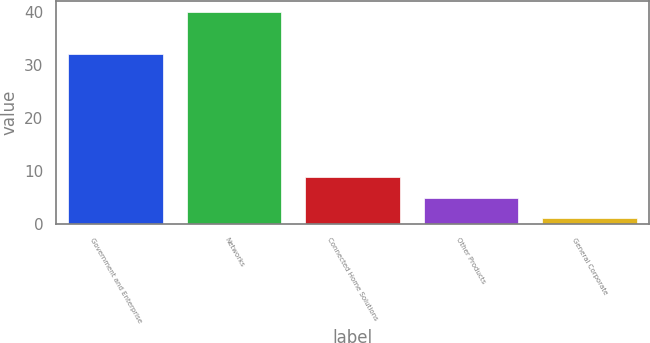Convert chart. <chart><loc_0><loc_0><loc_500><loc_500><bar_chart><fcel>Government and Enterprise<fcel>Networks<fcel>Connected Home Solutions<fcel>Other Products<fcel>General Corporate<nl><fcel>32<fcel>40<fcel>8.8<fcel>4.9<fcel>1<nl></chart> 